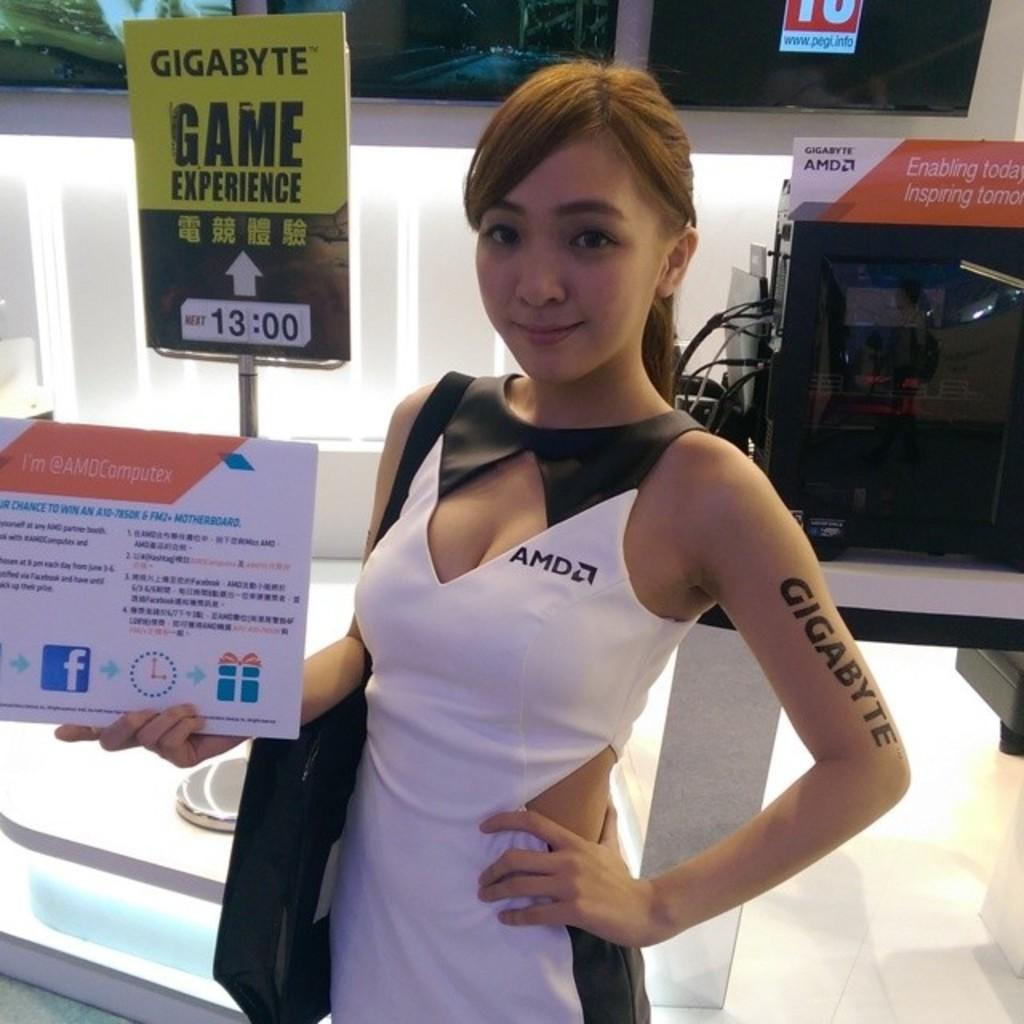Who is the main subject in the image? There is a woman in the image. What is the woman holding in her hand? The woman is holding a board in her hand. What is the woman wearing? The woman is wearing a bag. What can be seen in the background of the image? There is a board, a machine, a wall, and a window in the background of the image. Can you describe the setting where the image might have been taken? The image may have been taken in a hall. What type of sense does the woman have in the image? The image does not provide information about the woman's senses, so it cannot be determined from the image. How many pigs are present in the image? There are no pigs present in the image. 